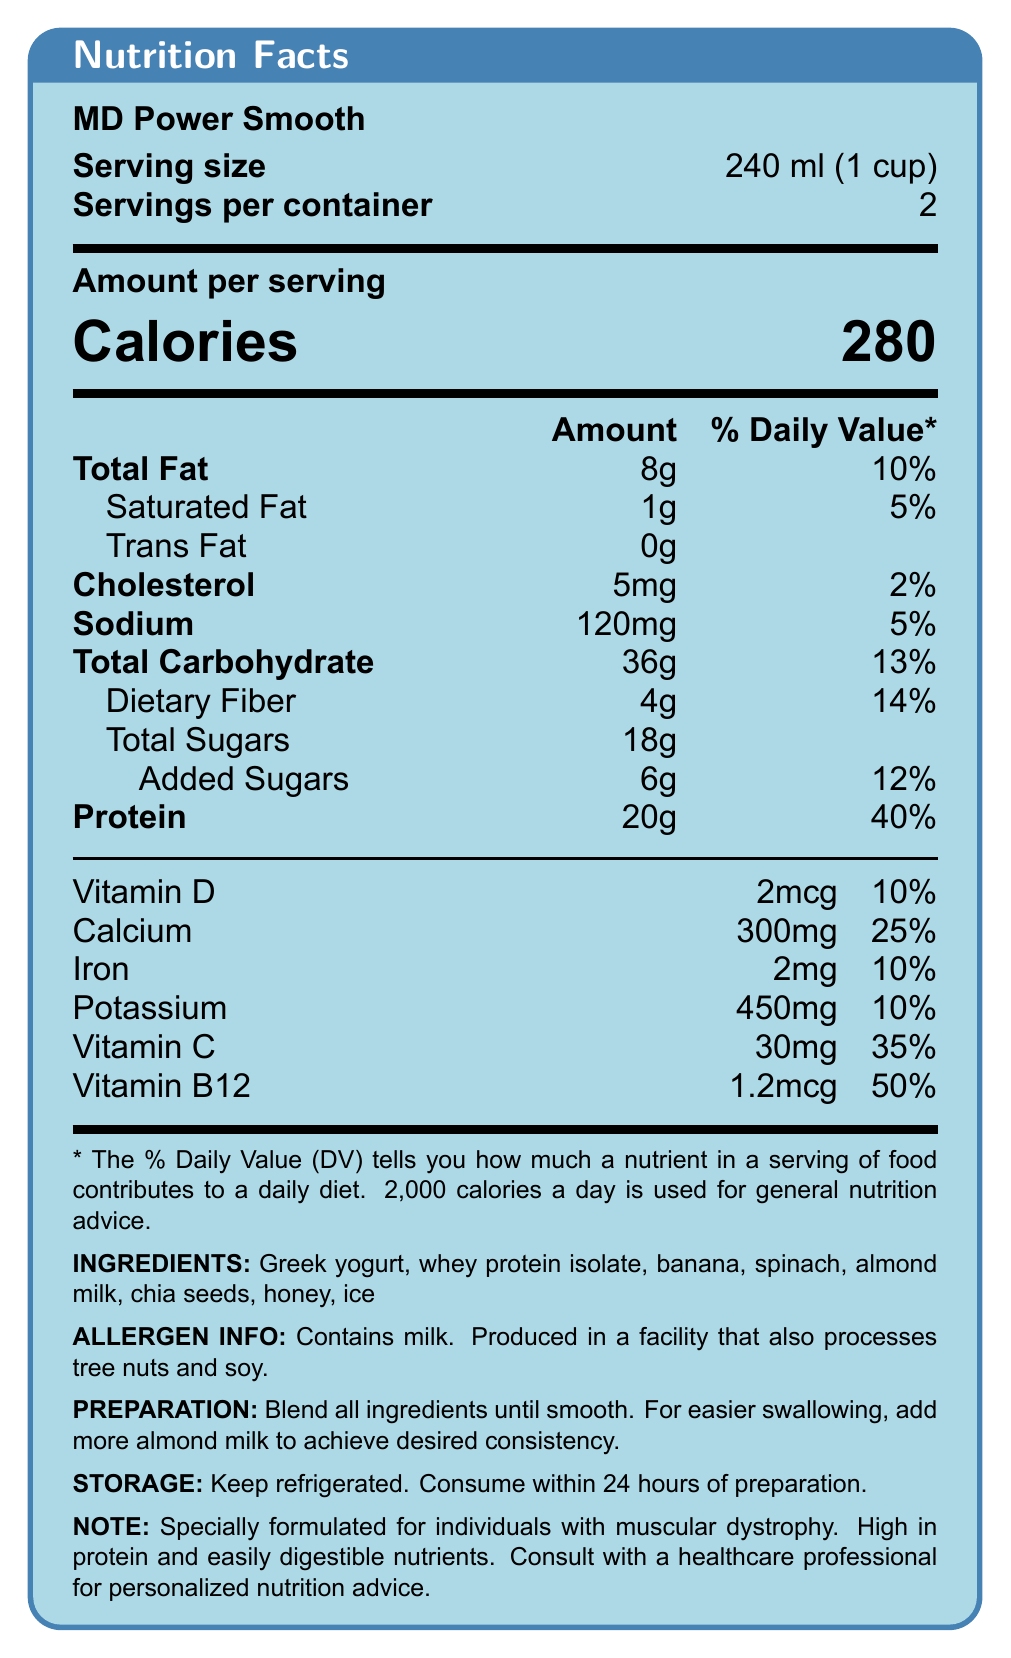what is the serving size for MD Power Smooth? The serving size listed at the top of the document is 240 ml (1 cup).
Answer: 240 ml (1 cup) how many servings are in each container? The document states that there are 2 servings per container.
Answer: 2 how many grams of protein are in one serving? The protein content per serving is 20g as listed in the nutrient section.
Answer: 20g what ingredients can be found in the MD Power Smooth? The ingredients section lists each of these components.
Answer: Greek yogurt, whey protein isolate, banana, spinach, almond milk, chia seeds, honey, ice what is the daily value percentage of calcium per serving? The percentage daily value of calcium per serving is 25%, as listed in the vitamin and mineral section.
Answer: 25% how much dietary fiber is in one serving? A. 1g B. 4g C. 18g D. 6g The dietary fiber content per serving is listed as 4g in the nutrient section.
Answer: B. 4g what is the amount of added sugars in one serving? A. 8g B. 12% C. 6g D. 18g The document specifies that the added sugar amount per serving is 6g.
Answer: C. 6g how many calories does each serving have? The total calories per serving is stated as 280 in the nutrient section.
Answer: 280 is the MD Power Smooth suitable for individuals with a soy allergy? The allergen info section indicates that it is produced in a facility that processes tree nuts and soy, which could be a concern for individuals with a soy allergy.
Answer: No how should the MD Power Smooth be stored after preparation? The storage instructions state that it should be kept refrigerated and consumed within 24 hours of preparation.
Answer: Keep refrigerated. Consume within 24 hours of preparation. what is the main idea of the document? The document includes detailed information about serving size, nutrient content, ingredients, potential allergens, and instructions for preparation and storage of the MD Power Smooth.
Answer: The document provides the nutrition facts, ingredients, allergen information, preparation and storage instructions, and some additional notes about the MD Power Smooth, which is a protein-packed, easy-to-swallow smoothie tailored for residents with muscular dystrophy. where was the MD Power Smooth developed? There is no information provided in the document about where the MD Power Smooth was developed.
Answer: Not enough information what percentage of the daily value of Vitamin D does one serving provide? The document states that one serving provides 2mcg of Vitamin D, which is 10% of the daily value.
Answer: 10% is the MD Power Smooth high in protein? The document indicates that one serving contains 20g of protein, which is 40% of the daily value, demonstrating that it is high in protein.
Answer: Yes 